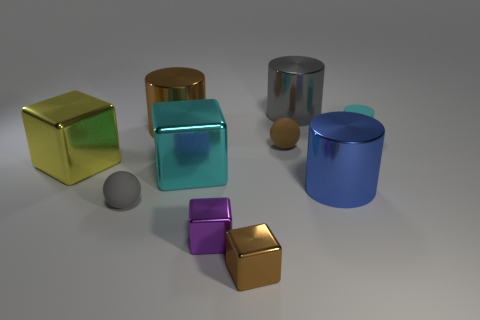Subtract all balls. How many objects are left? 8 Add 5 small gray rubber cylinders. How many small gray rubber cylinders exist? 5 Subtract 0 blue spheres. How many objects are left? 10 Subtract all purple metallic cubes. Subtract all brown balls. How many objects are left? 8 Add 1 tiny shiny objects. How many tiny shiny objects are left? 3 